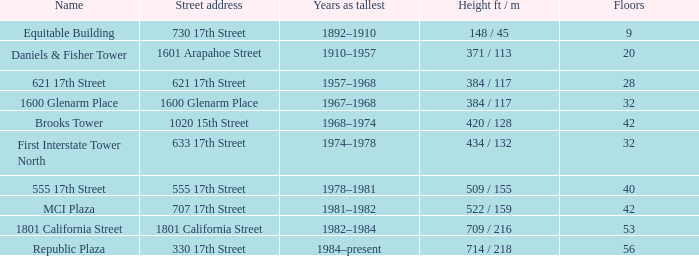What is the height of the building with 40 floors? 509 / 155. 